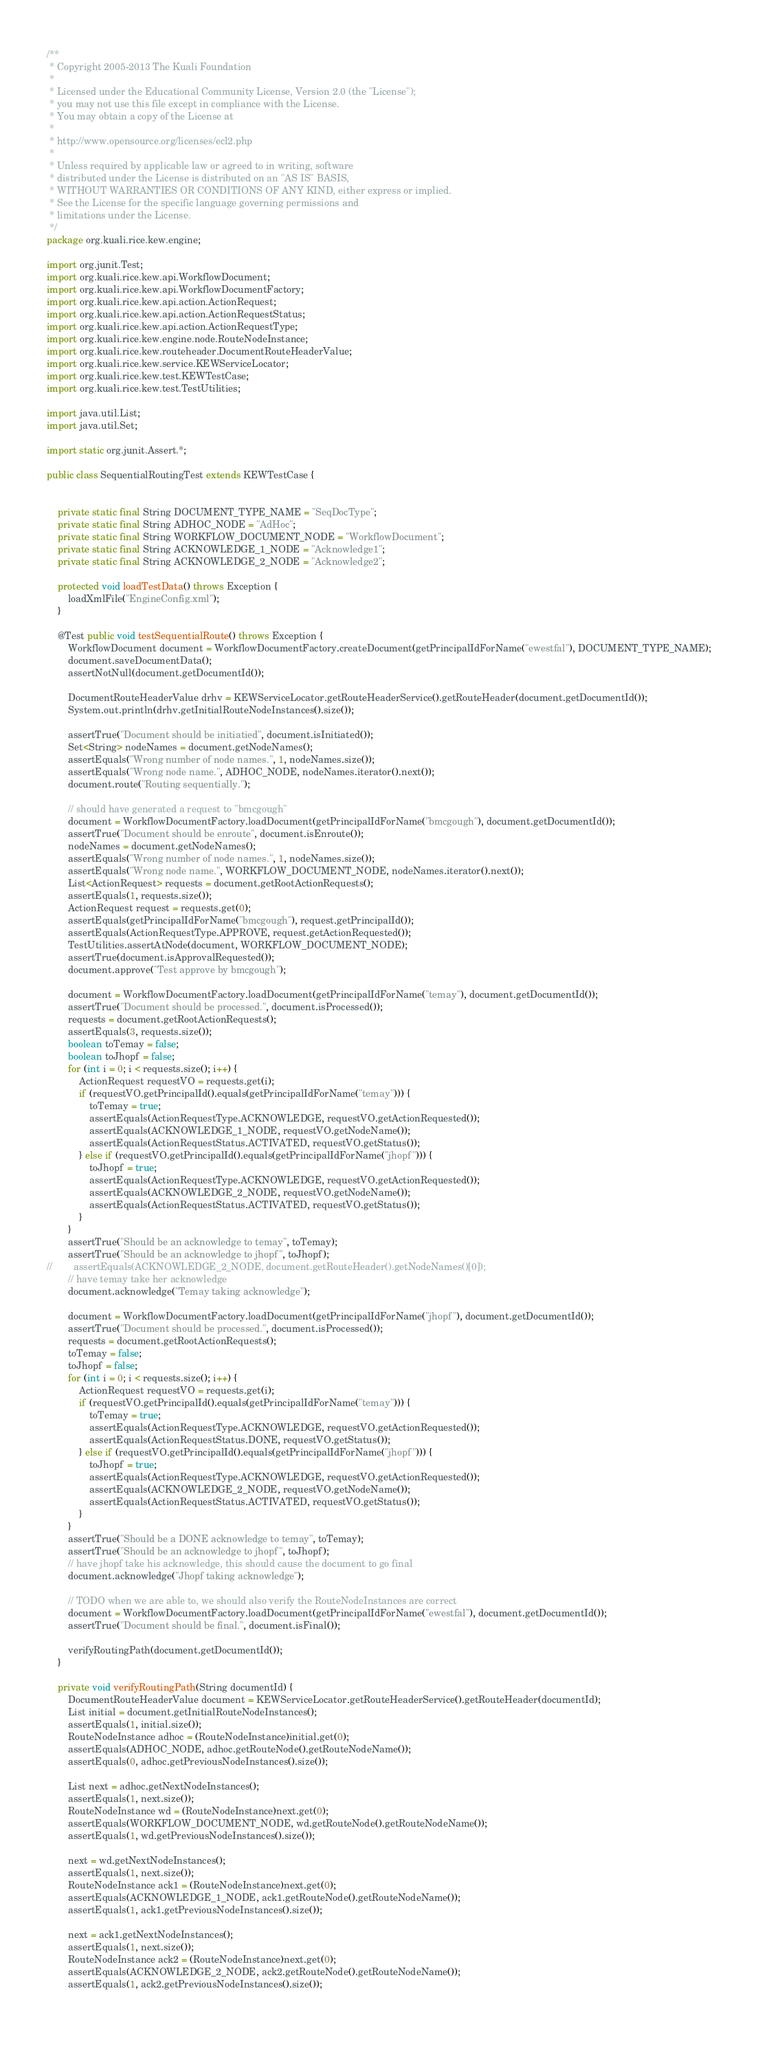<code> <loc_0><loc_0><loc_500><loc_500><_Java_>/**
 * Copyright 2005-2013 The Kuali Foundation
 *
 * Licensed under the Educational Community License, Version 2.0 (the "License");
 * you may not use this file except in compliance with the License.
 * You may obtain a copy of the License at
 *
 * http://www.opensource.org/licenses/ecl2.php
 *
 * Unless required by applicable law or agreed to in writing, software
 * distributed under the License is distributed on an "AS IS" BASIS,
 * WITHOUT WARRANTIES OR CONDITIONS OF ANY KIND, either express or implied.
 * See the License for the specific language governing permissions and
 * limitations under the License.
 */
package org.kuali.rice.kew.engine;

import org.junit.Test;
import org.kuali.rice.kew.api.WorkflowDocument;
import org.kuali.rice.kew.api.WorkflowDocumentFactory;
import org.kuali.rice.kew.api.action.ActionRequest;
import org.kuali.rice.kew.api.action.ActionRequestStatus;
import org.kuali.rice.kew.api.action.ActionRequestType;
import org.kuali.rice.kew.engine.node.RouteNodeInstance;
import org.kuali.rice.kew.routeheader.DocumentRouteHeaderValue;
import org.kuali.rice.kew.service.KEWServiceLocator;
import org.kuali.rice.kew.test.KEWTestCase;
import org.kuali.rice.kew.test.TestUtilities;

import java.util.List;
import java.util.Set;

import static org.junit.Assert.*;

public class SequentialRoutingTest extends KEWTestCase {
    
    
    private static final String DOCUMENT_TYPE_NAME = "SeqDocType";
	private static final String ADHOC_NODE = "AdHoc";
	private static final String WORKFLOW_DOCUMENT_NODE = "WorkflowDocument";
    private static final String ACKNOWLEDGE_1_NODE = "Acknowledge1";
    private static final String ACKNOWLEDGE_2_NODE = "Acknowledge2";
	    
    protected void loadTestData() throws Exception {
        loadXmlFile("EngineConfig.xml");
    }
        
    @Test public void testSequentialRoute() throws Exception {
    	WorkflowDocument document = WorkflowDocumentFactory.createDocument(getPrincipalIdForName("ewestfal"), DOCUMENT_TYPE_NAME);
    	document.saveDocumentData();
    	assertNotNull(document.getDocumentId());

        DocumentRouteHeaderValue drhv = KEWServiceLocator.getRouteHeaderService().getRouteHeader(document.getDocumentId());
        System.out.println(drhv.getInitialRouteNodeInstances().size());

    	assertTrue("Document should be initiatied", document.isInitiated());
    	Set<String> nodeNames = document.getNodeNames();
    	assertEquals("Wrong number of node names.", 1, nodeNames.size());
    	assertEquals("Wrong node name.", ADHOC_NODE, nodeNames.iterator().next());
    	document.route("Routing sequentially.");
        
        // should have generated a request to "bmcgough"
    	document = WorkflowDocumentFactory.loadDocument(getPrincipalIdForName("bmcgough"), document.getDocumentId());
        assertTrue("Document should be enroute", document.isEnroute());
    	nodeNames = document.getNodeNames();
    	assertEquals("Wrong number of node names.", 1, nodeNames.size());
    	assertEquals("Wrong node name.", WORKFLOW_DOCUMENT_NODE, nodeNames.iterator().next());
        List<ActionRequest> requests = document.getRootActionRequests();
        assertEquals(1, requests.size());
        ActionRequest request = requests.get(0);
        assertEquals(getPrincipalIdForName("bmcgough"), request.getPrincipalId());
        assertEquals(ActionRequestType.APPROVE, request.getActionRequested());
        TestUtilities.assertAtNode(document, WORKFLOW_DOCUMENT_NODE);
        assertTrue(document.isApprovalRequested());
        document.approve("Test approve by bmcgough");
        
        document = WorkflowDocumentFactory.loadDocument(getPrincipalIdForName("temay"), document.getDocumentId());
        assertTrue("Document should be processed.", document.isProcessed());
        requests = document.getRootActionRequests();
        assertEquals(3, requests.size());
        boolean toTemay = false;
        boolean toJhopf = false;
        for (int i = 0; i < requests.size(); i++) {
            ActionRequest requestVO = requests.get(i);
            if (requestVO.getPrincipalId().equals(getPrincipalIdForName("temay"))) {
                toTemay = true;
                assertEquals(ActionRequestType.ACKNOWLEDGE, requestVO.getActionRequested());
                assertEquals(ACKNOWLEDGE_1_NODE, requestVO.getNodeName());
                assertEquals(ActionRequestStatus.ACTIVATED, requestVO.getStatus());
            } else if (requestVO.getPrincipalId().equals(getPrincipalIdForName("jhopf"))) {
                toJhopf = true;
                assertEquals(ActionRequestType.ACKNOWLEDGE, requestVO.getActionRequested());
                assertEquals(ACKNOWLEDGE_2_NODE, requestVO.getNodeName());
                assertEquals(ActionRequestStatus.ACTIVATED, requestVO.getStatus());
            }
        }
        assertTrue("Should be an acknowledge to temay", toTemay);
        assertTrue("Should be an acknowledge to jhopf", toJhopf);
//        assertEquals(ACKNOWLEDGE_2_NODE, document.getRouteHeader().getNodeNames()[0]);
        // have temay take her acknowledge
        document.acknowledge("Temay taking acknowledge");
        
        document = WorkflowDocumentFactory.loadDocument(getPrincipalIdForName("jhopf"), document.getDocumentId());
        assertTrue("Document should be processed.", document.isProcessed());
        requests = document.getRootActionRequests();
        toTemay = false;
        toJhopf = false;
        for (int i = 0; i < requests.size(); i++) {
            ActionRequest requestVO = requests.get(i);
            if (requestVO.getPrincipalId().equals(getPrincipalIdForName("temay"))) {
                toTemay = true;
                assertEquals(ActionRequestType.ACKNOWLEDGE, requestVO.getActionRequested());
                assertEquals(ActionRequestStatus.DONE, requestVO.getStatus());
            } else if (requestVO.getPrincipalId().equals(getPrincipalIdForName("jhopf"))) {
                toJhopf = true;
                assertEquals(ActionRequestType.ACKNOWLEDGE, requestVO.getActionRequested());
                assertEquals(ACKNOWLEDGE_2_NODE, requestVO.getNodeName());
                assertEquals(ActionRequestStatus.ACTIVATED, requestVO.getStatus());
            }
        }
        assertTrue("Should be a DONE acknowledge to temay", toTemay);
        assertTrue("Should be an acknowledge to jhopf", toJhopf);
        // have jhopf take his acknowledge, this should cause the document to go final
        document.acknowledge("Jhopf taking acknowledge");
        
    	// TODO when we are able to, we should also verify the RouteNodeInstances are correct
        document = WorkflowDocumentFactory.loadDocument(getPrincipalIdForName("ewestfal"), document.getDocumentId());
    	assertTrue("Document should be final.", document.isFinal());
        
        verifyRoutingPath(document.getDocumentId());
    }        

    private void verifyRoutingPath(String documentId) {
        DocumentRouteHeaderValue document = KEWServiceLocator.getRouteHeaderService().getRouteHeader(documentId);
        List initial = document.getInitialRouteNodeInstances();
        assertEquals(1, initial.size());
        RouteNodeInstance adhoc = (RouteNodeInstance)initial.get(0);
        assertEquals(ADHOC_NODE, adhoc.getRouteNode().getRouteNodeName());
        assertEquals(0, adhoc.getPreviousNodeInstances().size());
        
        List next = adhoc.getNextNodeInstances();
        assertEquals(1, next.size());
        RouteNodeInstance wd = (RouteNodeInstance)next.get(0);
        assertEquals(WORKFLOW_DOCUMENT_NODE, wd.getRouteNode().getRouteNodeName());
        assertEquals(1, wd.getPreviousNodeInstances().size());
        
        next = wd.getNextNodeInstances();
        assertEquals(1, next.size());
        RouteNodeInstance ack1 = (RouteNodeInstance)next.get(0);
        assertEquals(ACKNOWLEDGE_1_NODE, ack1.getRouteNode().getRouteNodeName());
        assertEquals(1, ack1.getPreviousNodeInstances().size());
        
        next = ack1.getNextNodeInstances();
        assertEquals(1, next.size());
        RouteNodeInstance ack2 = (RouteNodeInstance)next.get(0);
        assertEquals(ACKNOWLEDGE_2_NODE, ack2.getRouteNode().getRouteNodeName());
        assertEquals(1, ack2.getPreviousNodeInstances().size());
        </code> 